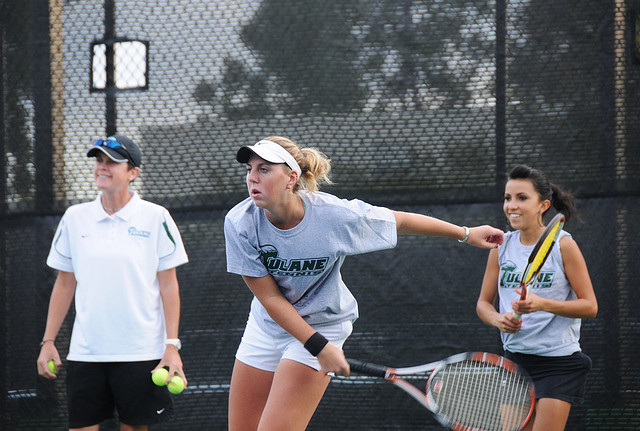Please identify all text content in this image. TULANE 